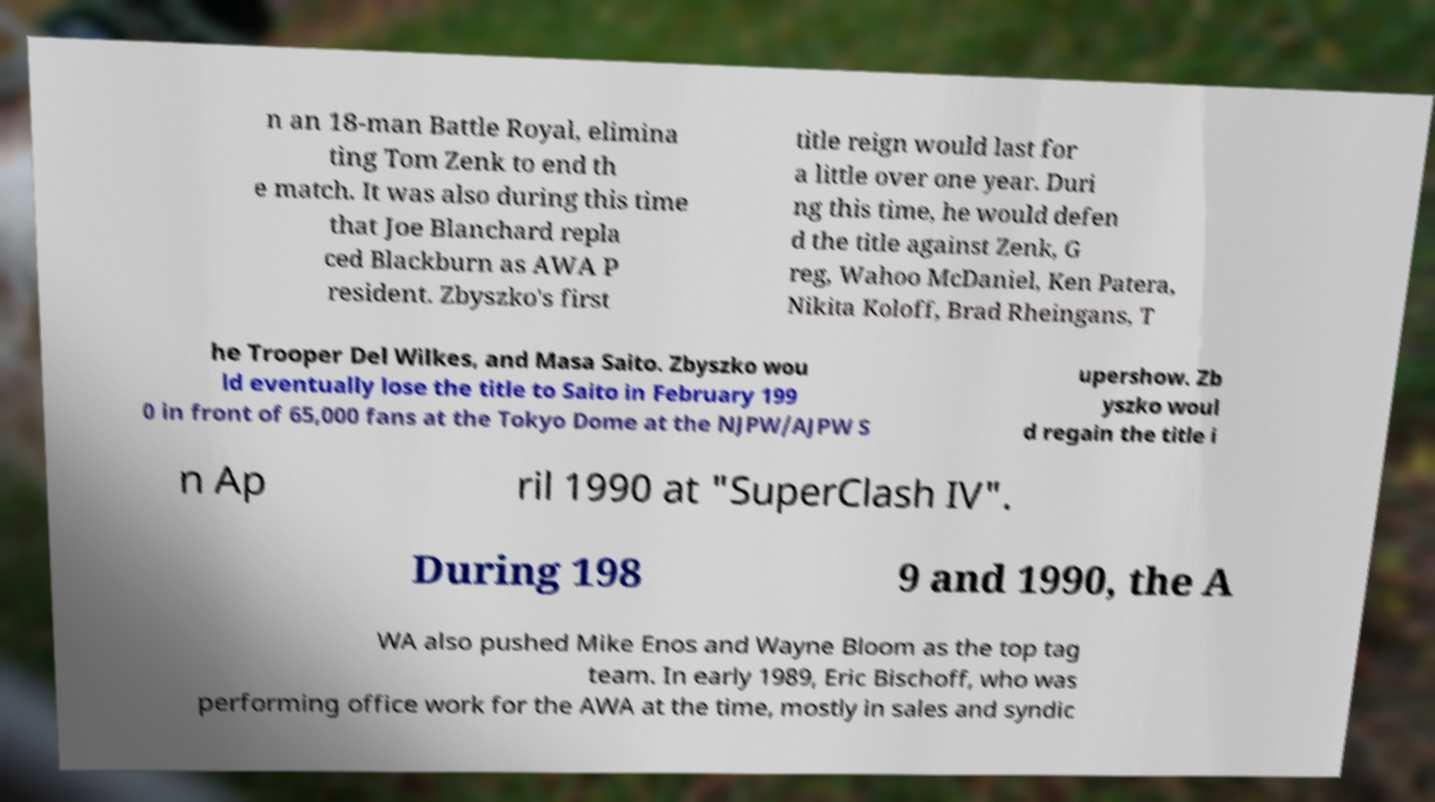Could you assist in decoding the text presented in this image and type it out clearly? n an 18-man Battle Royal, elimina ting Tom Zenk to end th e match. It was also during this time that Joe Blanchard repla ced Blackburn as AWA P resident. Zbyszko's first title reign would last for a little over one year. Duri ng this time, he would defen d the title against Zenk, G reg, Wahoo McDaniel, Ken Patera, Nikita Koloff, Brad Rheingans, T he Trooper Del Wilkes, and Masa Saito. Zbyszko wou ld eventually lose the title to Saito in February 199 0 in front of 65,000 fans at the Tokyo Dome at the NJPW/AJPW S upershow. Zb yszko woul d regain the title i n Ap ril 1990 at "SuperClash IV". During 198 9 and 1990, the A WA also pushed Mike Enos and Wayne Bloom as the top tag team. In early 1989, Eric Bischoff, who was performing office work for the AWA at the time, mostly in sales and syndic 